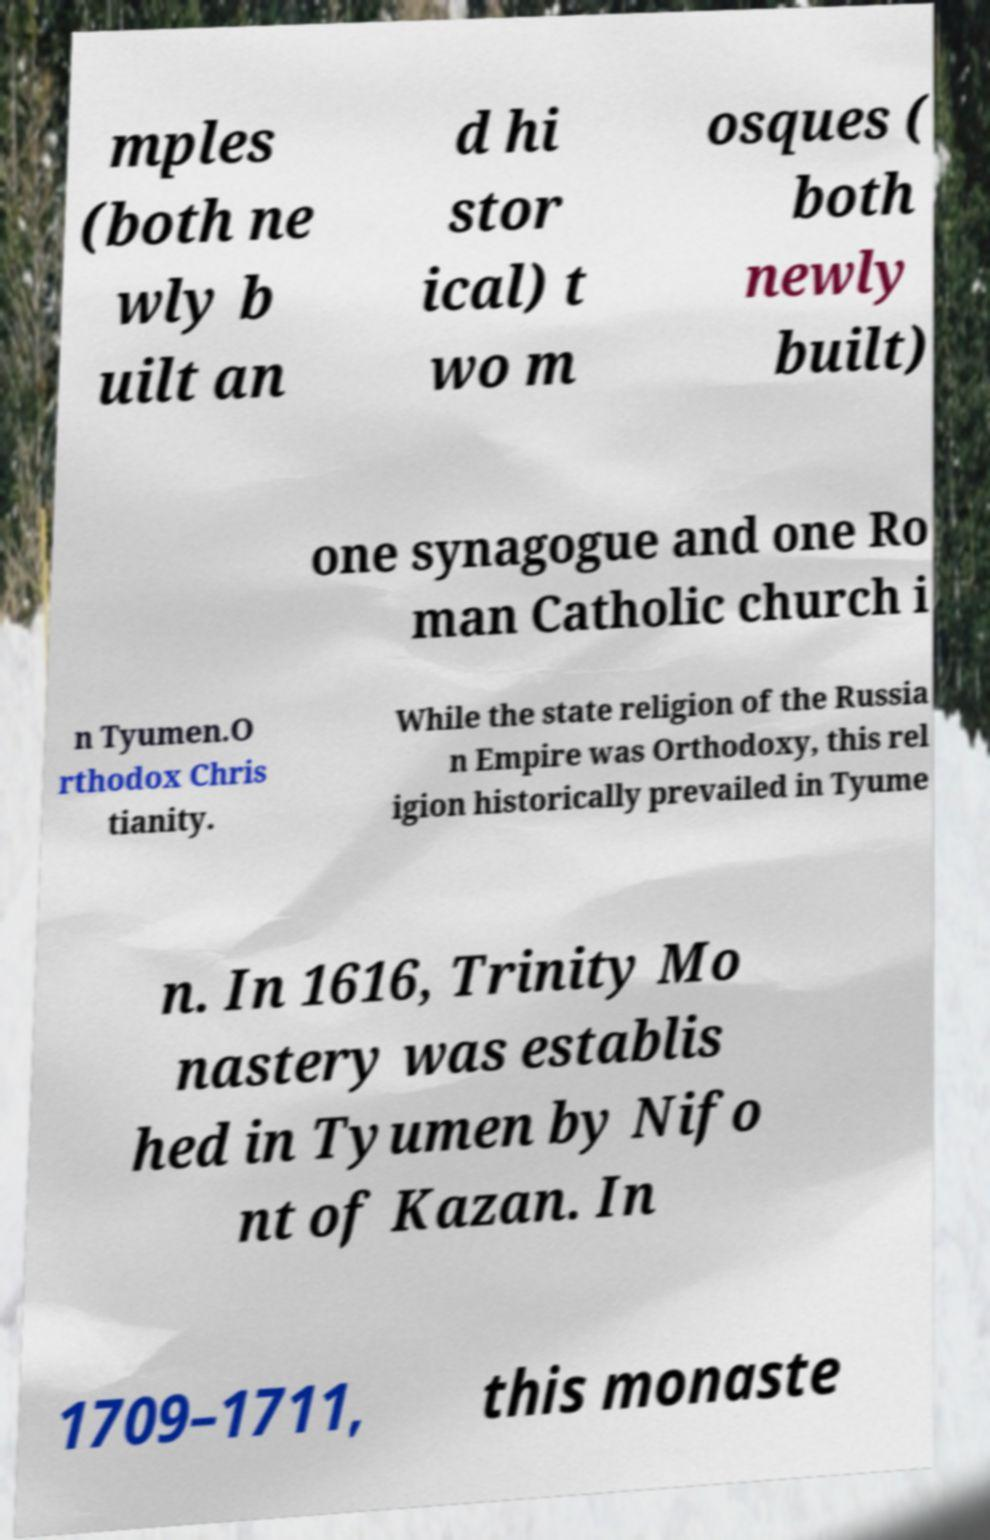Can you read and provide the text displayed in the image?This photo seems to have some interesting text. Can you extract and type it out for me? mples (both ne wly b uilt an d hi stor ical) t wo m osques ( both newly built) one synagogue and one Ro man Catholic church i n Tyumen.O rthodox Chris tianity. While the state religion of the Russia n Empire was Orthodoxy, this rel igion historically prevailed in Tyume n. In 1616, Trinity Mo nastery was establis hed in Tyumen by Nifo nt of Kazan. In 1709–1711, this monaste 